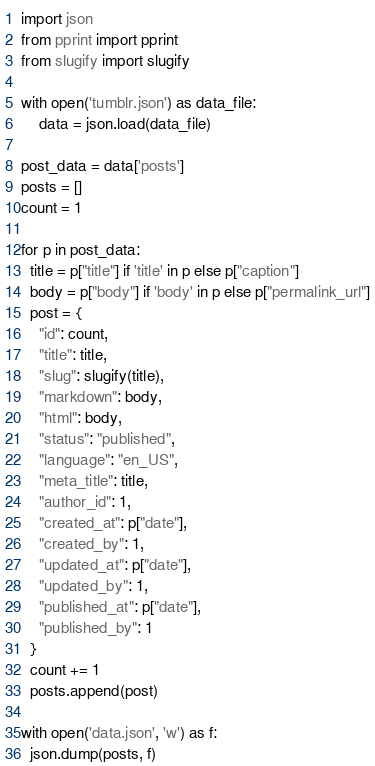<code> <loc_0><loc_0><loc_500><loc_500><_Python_>import json
from pprint import pprint
from slugify import slugify

with open('tumblr.json') as data_file:
    data = json.load(data_file)

post_data = data['posts']
posts = []
count = 1

for p in post_data:
  title = p["title"] if 'title' in p else p["caption"]
  body = p["body"] if 'body' in p else p["permalink_url"]
  post = {
    "id": count,
    "title": title,
    "slug": slugify(title),
    "markdown": body,
    "html": body,
    "status": "published",
    "language": "en_US",
    "meta_title": title,
    "author_id": 1,
    "created_at": p["date"],
    "created_by": 1,
    "updated_at": p["date"],
    "updated_by": 1,
    "published_at": p["date"],
    "published_by": 1
  }
  count += 1
  posts.append(post)

with open('data.json', 'w') as f:
  json.dump(posts, f)
</code> 